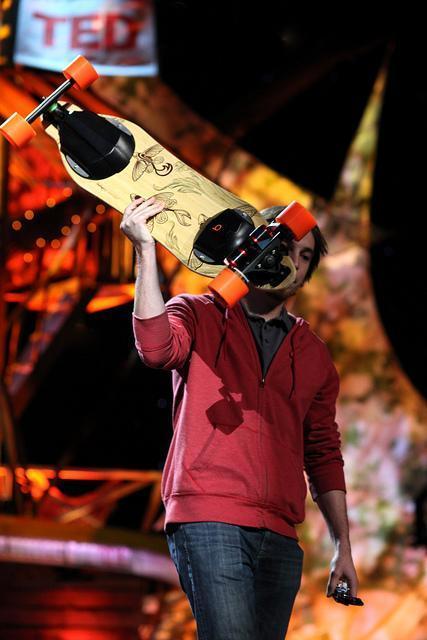How many candles are lit in the cake on the table?
Give a very brief answer. 0. 